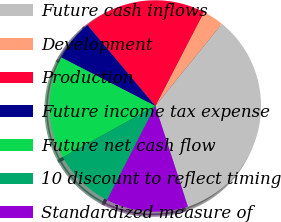Convert chart to OTSL. <chart><loc_0><loc_0><loc_500><loc_500><pie_chart><fcel>Future cash inflows<fcel>Development<fcel>Production<fcel>Future income tax expense<fcel>Future net cash flow<fcel>10 discount to reflect timing<fcel>Standardized measure of<nl><fcel>34.18%<fcel>3.23%<fcel>18.71%<fcel>6.33%<fcel>15.61%<fcel>9.42%<fcel>12.52%<nl></chart> 